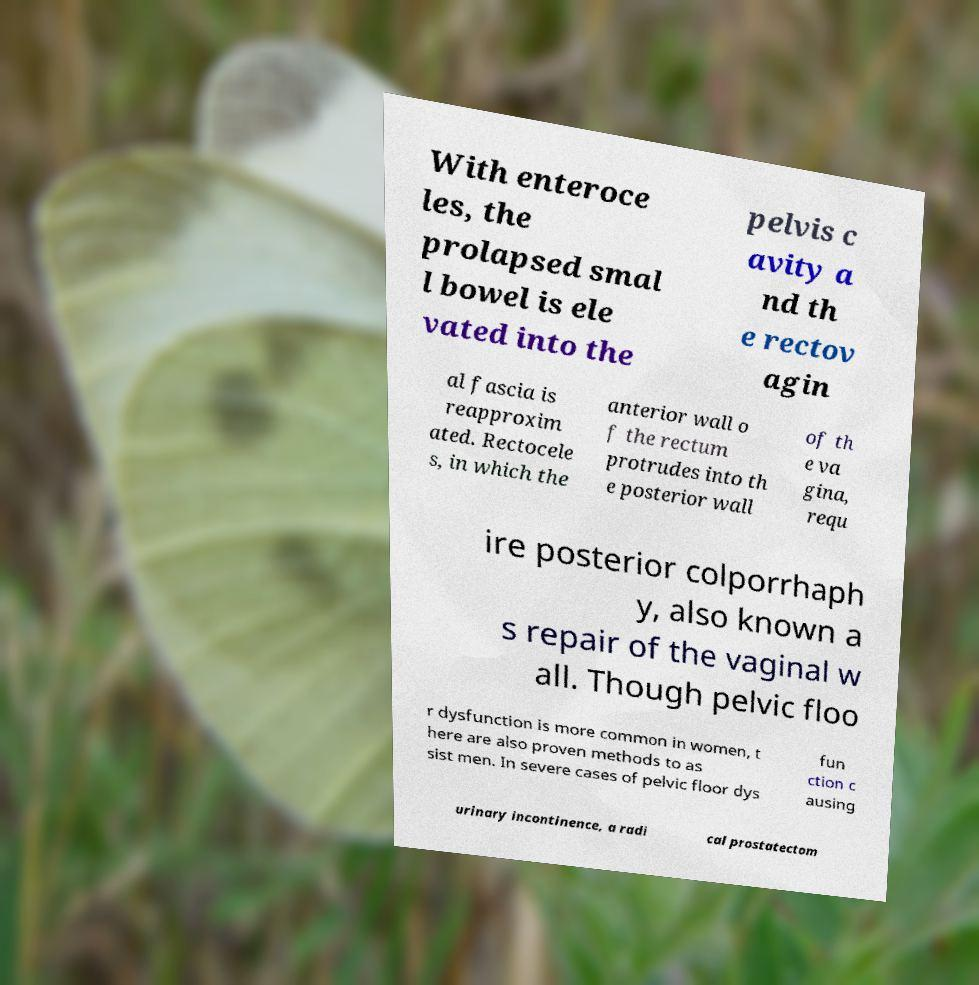What messages or text are displayed in this image? I need them in a readable, typed format. With enteroce les, the prolapsed smal l bowel is ele vated into the pelvis c avity a nd th e rectov agin al fascia is reapproxim ated. Rectocele s, in which the anterior wall o f the rectum protrudes into th e posterior wall of th e va gina, requ ire posterior colporrhaph y, also known a s repair of the vaginal w all. Though pelvic floo r dysfunction is more common in women, t here are also proven methods to as sist men. In severe cases of pelvic floor dys fun ction c ausing urinary incontinence, a radi cal prostatectom 